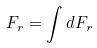<formula> <loc_0><loc_0><loc_500><loc_500>F _ { r } = \int d F _ { r }</formula> 